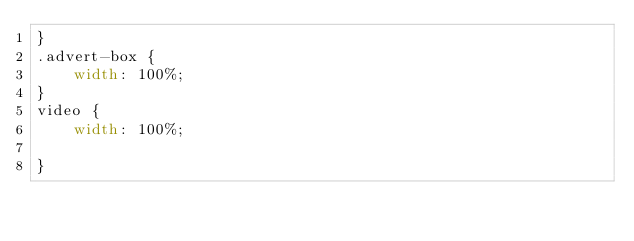<code> <loc_0><loc_0><loc_500><loc_500><_CSS_>}
.advert-box {
	width: 100%;
}
video {
	width: 100%;

}
</code> 